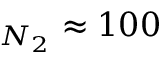Convert formula to latex. <formula><loc_0><loc_0><loc_500><loc_500>_ { N _ { 2 } } \approx 1 0 0</formula> 